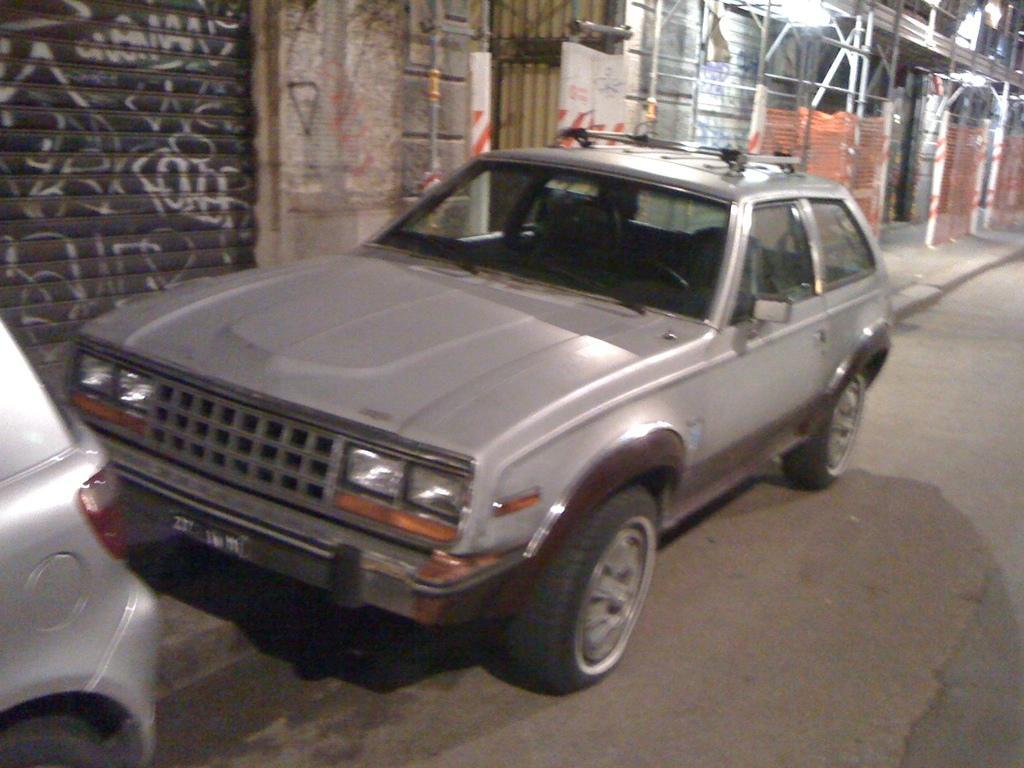In one or two sentences, can you explain what this image depicts? In this image we can see motor vehicles on the road and buildings and grills in the background. 